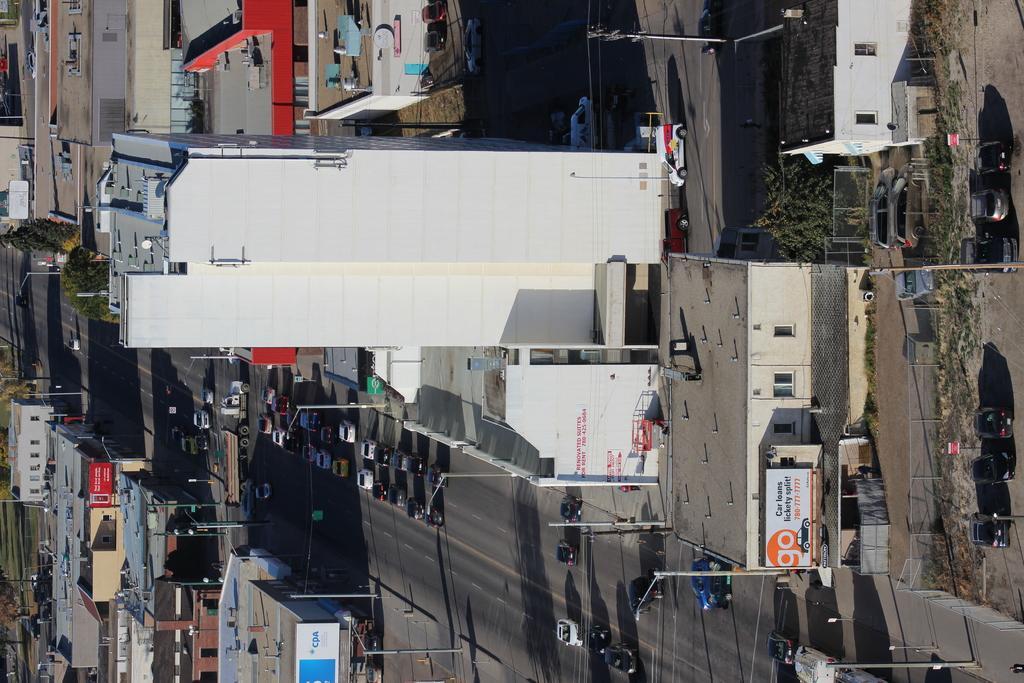In one or two sentences, can you explain what this image depicts? In the picture I can see buildings, vehicles on roads, fence, trees, plants, pole lights, boards and some other objects on the ground. 